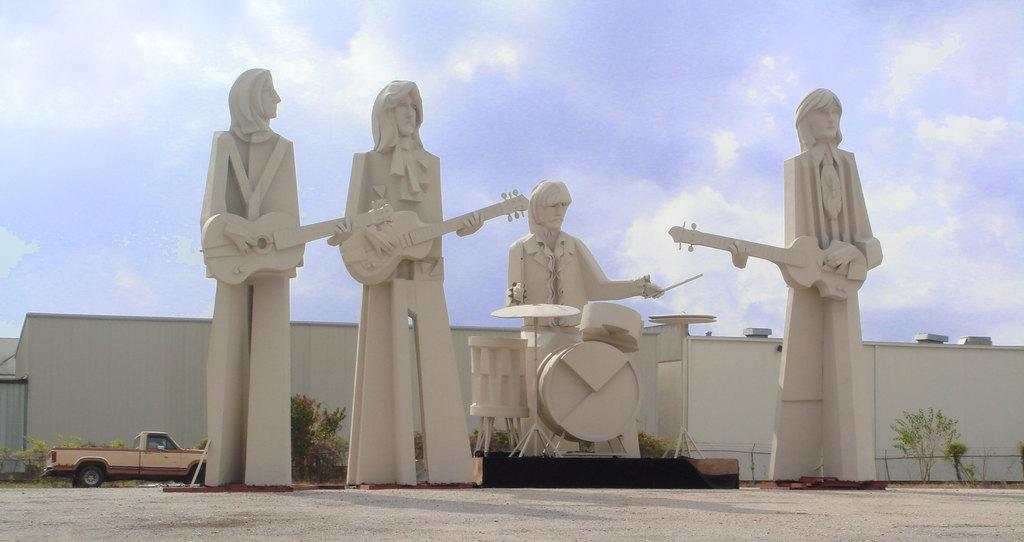What are the sculptures in the image depicting? The sculptures in the image are of people playing musical instruments. What else can be seen in the image besides the sculptures? There is a vehicle, plants, houses, and the sky visible in the image. What news is being broadcasted from the vehicle in the image? There is no indication in the image that the vehicle is broadcasting news or any other information. 